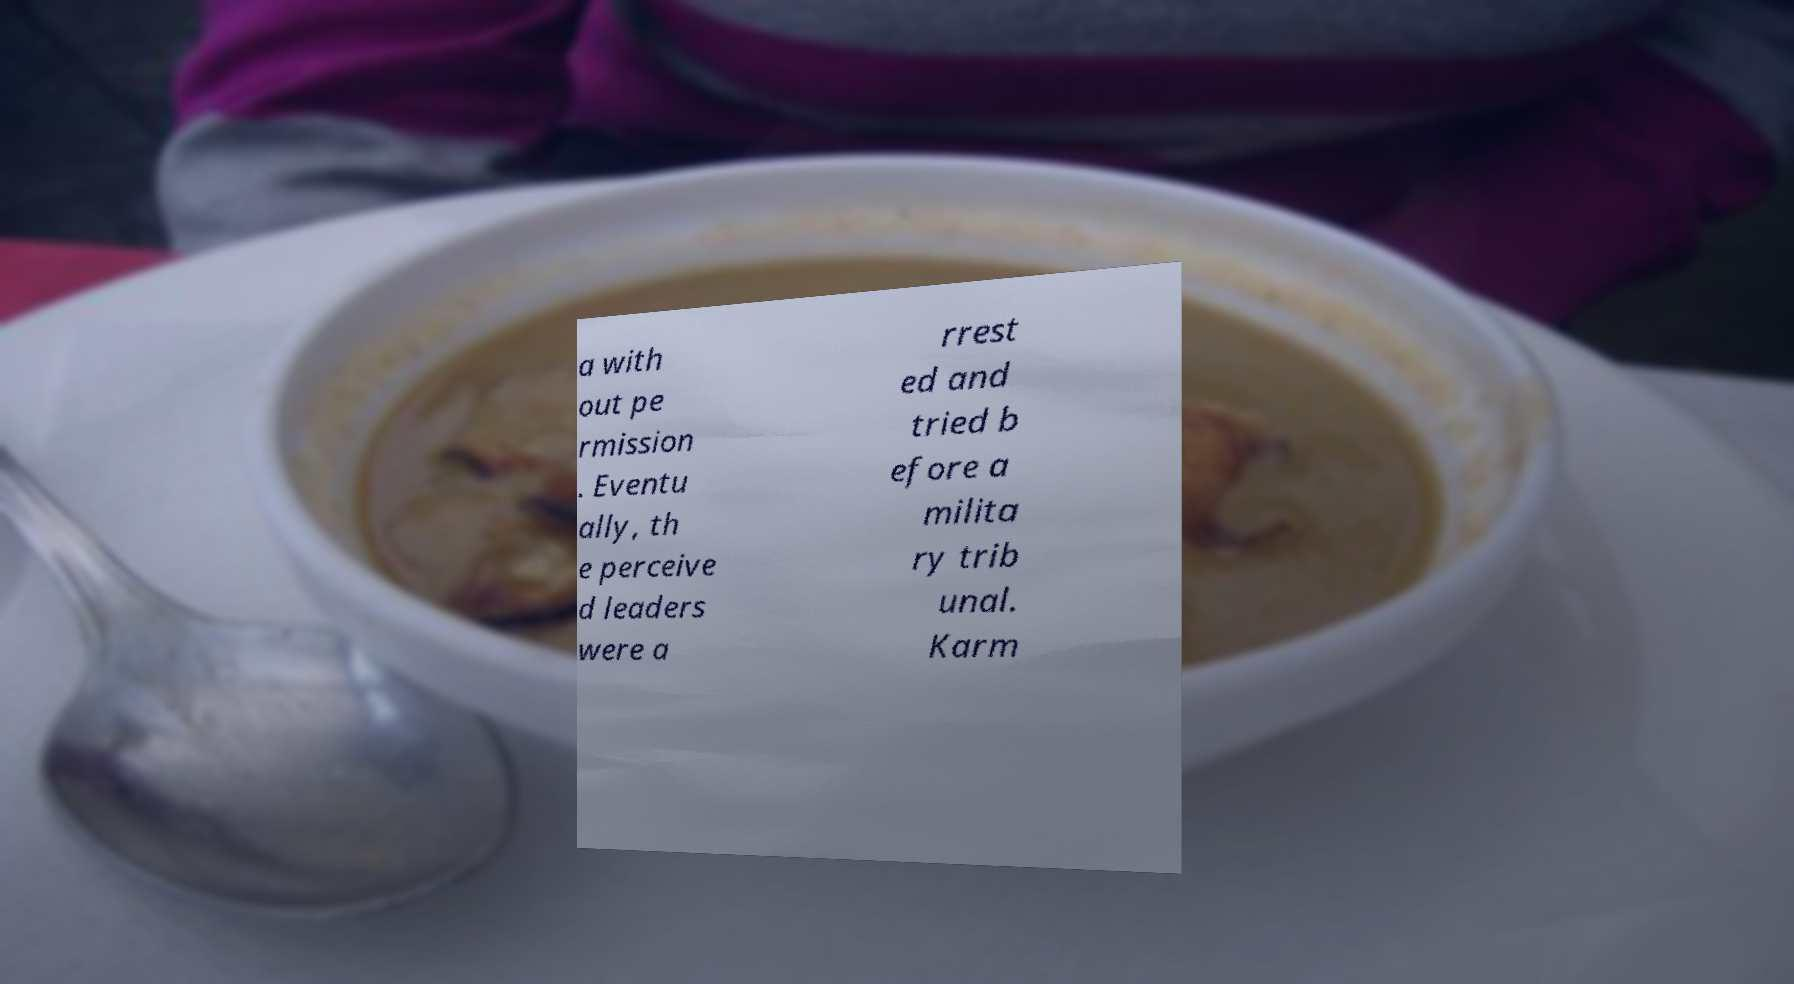For documentation purposes, I need the text within this image transcribed. Could you provide that? a with out pe rmission . Eventu ally, th e perceive d leaders were a rrest ed and tried b efore a milita ry trib unal. Karm 